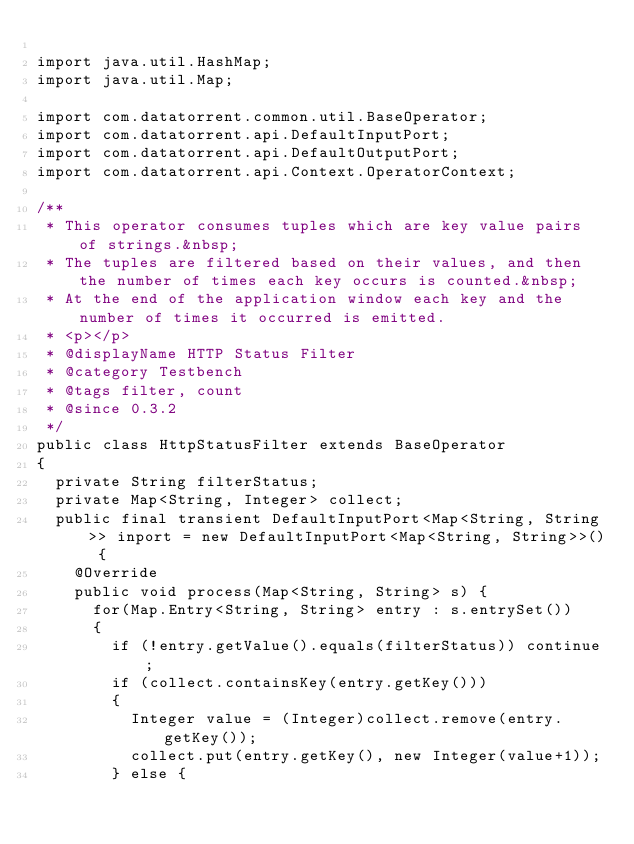Convert code to text. <code><loc_0><loc_0><loc_500><loc_500><_Java_>
import java.util.HashMap;
import java.util.Map;

import com.datatorrent.common.util.BaseOperator;
import com.datatorrent.api.DefaultInputPort;
import com.datatorrent.api.DefaultOutputPort;
import com.datatorrent.api.Context.OperatorContext;

/**
 * This operator consumes tuples which are key value pairs of strings.&nbsp;
 * The tuples are filtered based on their values, and then the number of times each key occurs is counted.&nbsp;
 * At the end of the application window each key and the number of times it occurred is emitted.
 * <p></p>
 * @displayName HTTP Status Filter
 * @category Testbench
 * @tags filter, count
 * @since 0.3.2
 */
public class HttpStatusFilter extends BaseOperator
{
	private String filterStatus;
	private Map<String, Integer> collect;
	public final transient DefaultInputPort<Map<String, String>> inport = new DefaultInputPort<Map<String, String>>() {
    @Override
    public void process(Map<String, String> s) {
    	for(Map.Entry<String, String> entry : s.entrySet())
    	{
    		if (!entry.getValue().equals(filterStatus)) continue;
	    	if (collect.containsKey(entry.getKey()))
	    	{
	    		Integer value = (Integer)collect.remove(entry.getKey());
	    		collect.put(entry.getKey(), new Integer(value+1));
	    	} else {</code> 